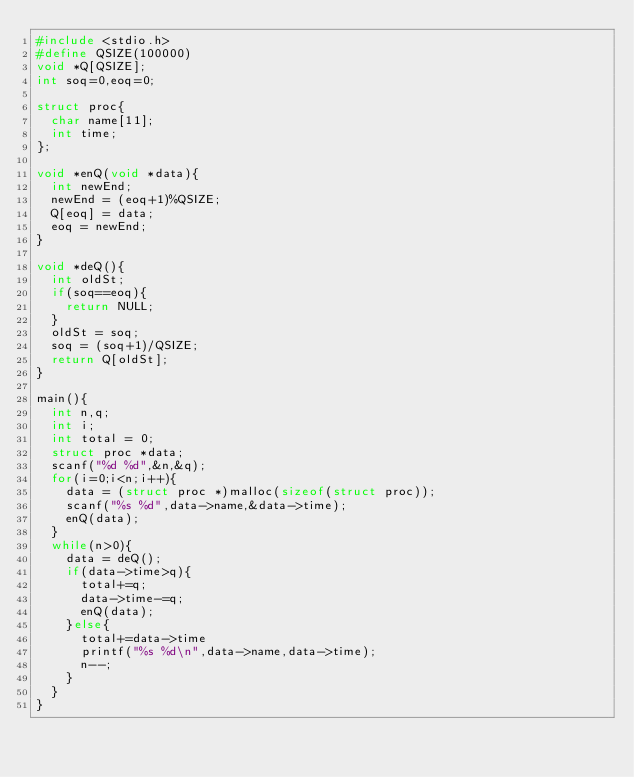Convert code to text. <code><loc_0><loc_0><loc_500><loc_500><_C++_>#include <stdio.h>
#define QSIZE(100000)
void *Q[QSIZE];
int soq=0,eoq=0;

struct proc{
  char name[11];
  int time;
};

void *enQ(void *data){
  int newEnd;  
  newEnd = (eoq+1)%QSIZE;
  Q[eoq] = data;
  eoq = newEnd;
}

void *deQ(){
  int oldSt;
  if(soq==eoq){
    return NULL;
  }
  oldSt = soq;
  soq = (soq+1)/QSIZE;
  return Q[oldSt];
}

main(){
  int n,q;
  int i;
  int total = 0;
  struct proc *data;
  scanf("%d %d",&n,&q);
  for(i=0;i<n;i++){
    data = (struct proc *)malloc(sizeof(struct proc));
    scanf("%s %d",data->name,&data->time);
    enQ(data);
  }
  while(n>0){
    data = deQ();
    if(data->time>q){
      total+=q;
      data->time-=q;
      enQ(data);
    }else{
      total+=data->time
      printf("%s %d\n",data->name,data->time);
      n--;
    }
  }
}</code> 